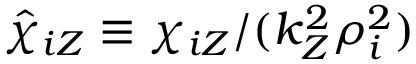<formula> <loc_0><loc_0><loc_500><loc_500>\hat { \chi } _ { i Z } \equiv \chi _ { i Z } / ( k _ { Z } ^ { 2 } \rho _ { i } ^ { 2 } )</formula> 